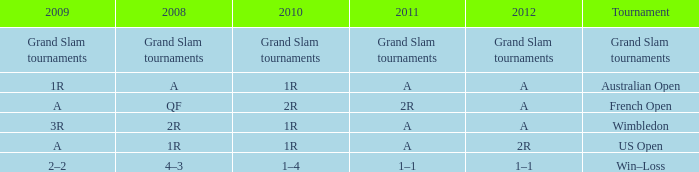Name the 2009 ffor 2010 of 1r and 2012 of a and 2008 of 2r 3R. 